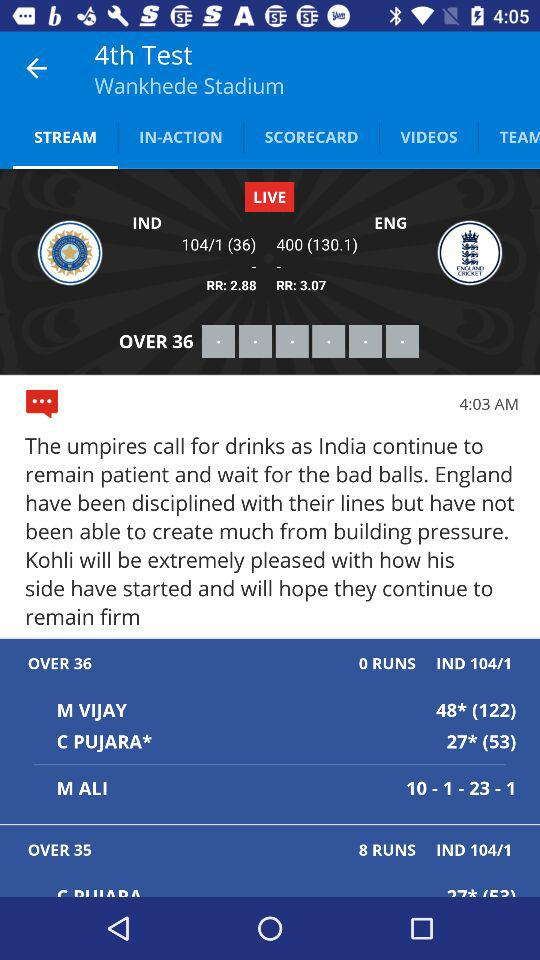How many overs has "India" played? "India" has played 36 overs. 